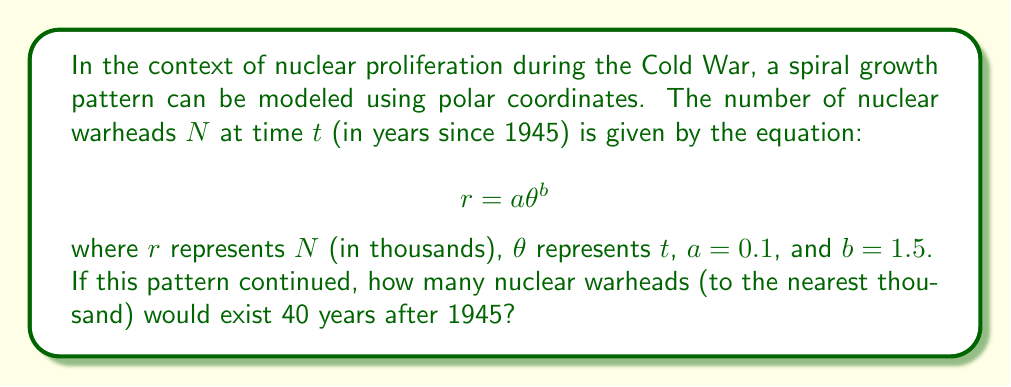Can you solve this math problem? To solve this problem, we need to follow these steps:

1) First, we identify that $\theta = 40$ years, as we're looking at the situation 40 years after 1945.

2) We're given the equation $r = a\theta^b$, where:
   $a = 0.1$
   $b = 1.5$
   $\theta = 40$

3) Let's substitute these values into the equation:

   $$r = 0.1 \cdot 40^{1.5}$$

4) Now we can calculate:
   
   $$r = 0.1 \cdot 40^{1.5} = 0.1 \cdot 40 \cdot \sqrt{40} \approx 25.2984$$

5) Remember that $r$ represents the number of warheads in thousands. So we need to multiply by 1000:

   $$25.2984 \cdot 1000 \approx 25,298.4$$

6) The question asks for the answer to the nearest thousand, so we round this to 25,000.

This model suggests that if the spiral growth pattern of nuclear proliferation continued as described, there would be approximately 25,000 nuclear warheads 40 years after 1945 (i.e., in 1985).
Answer: 25,000 nuclear warheads 